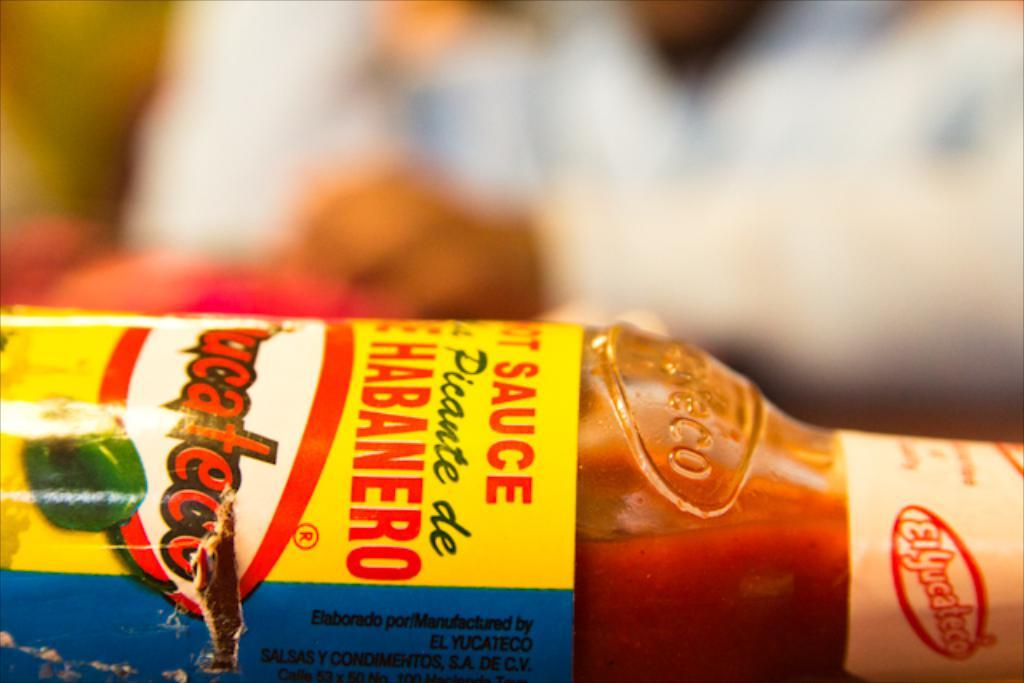Provide a one-sentence caption for the provided image. A bottle of El Yucateco's Habanero hot sauce. 